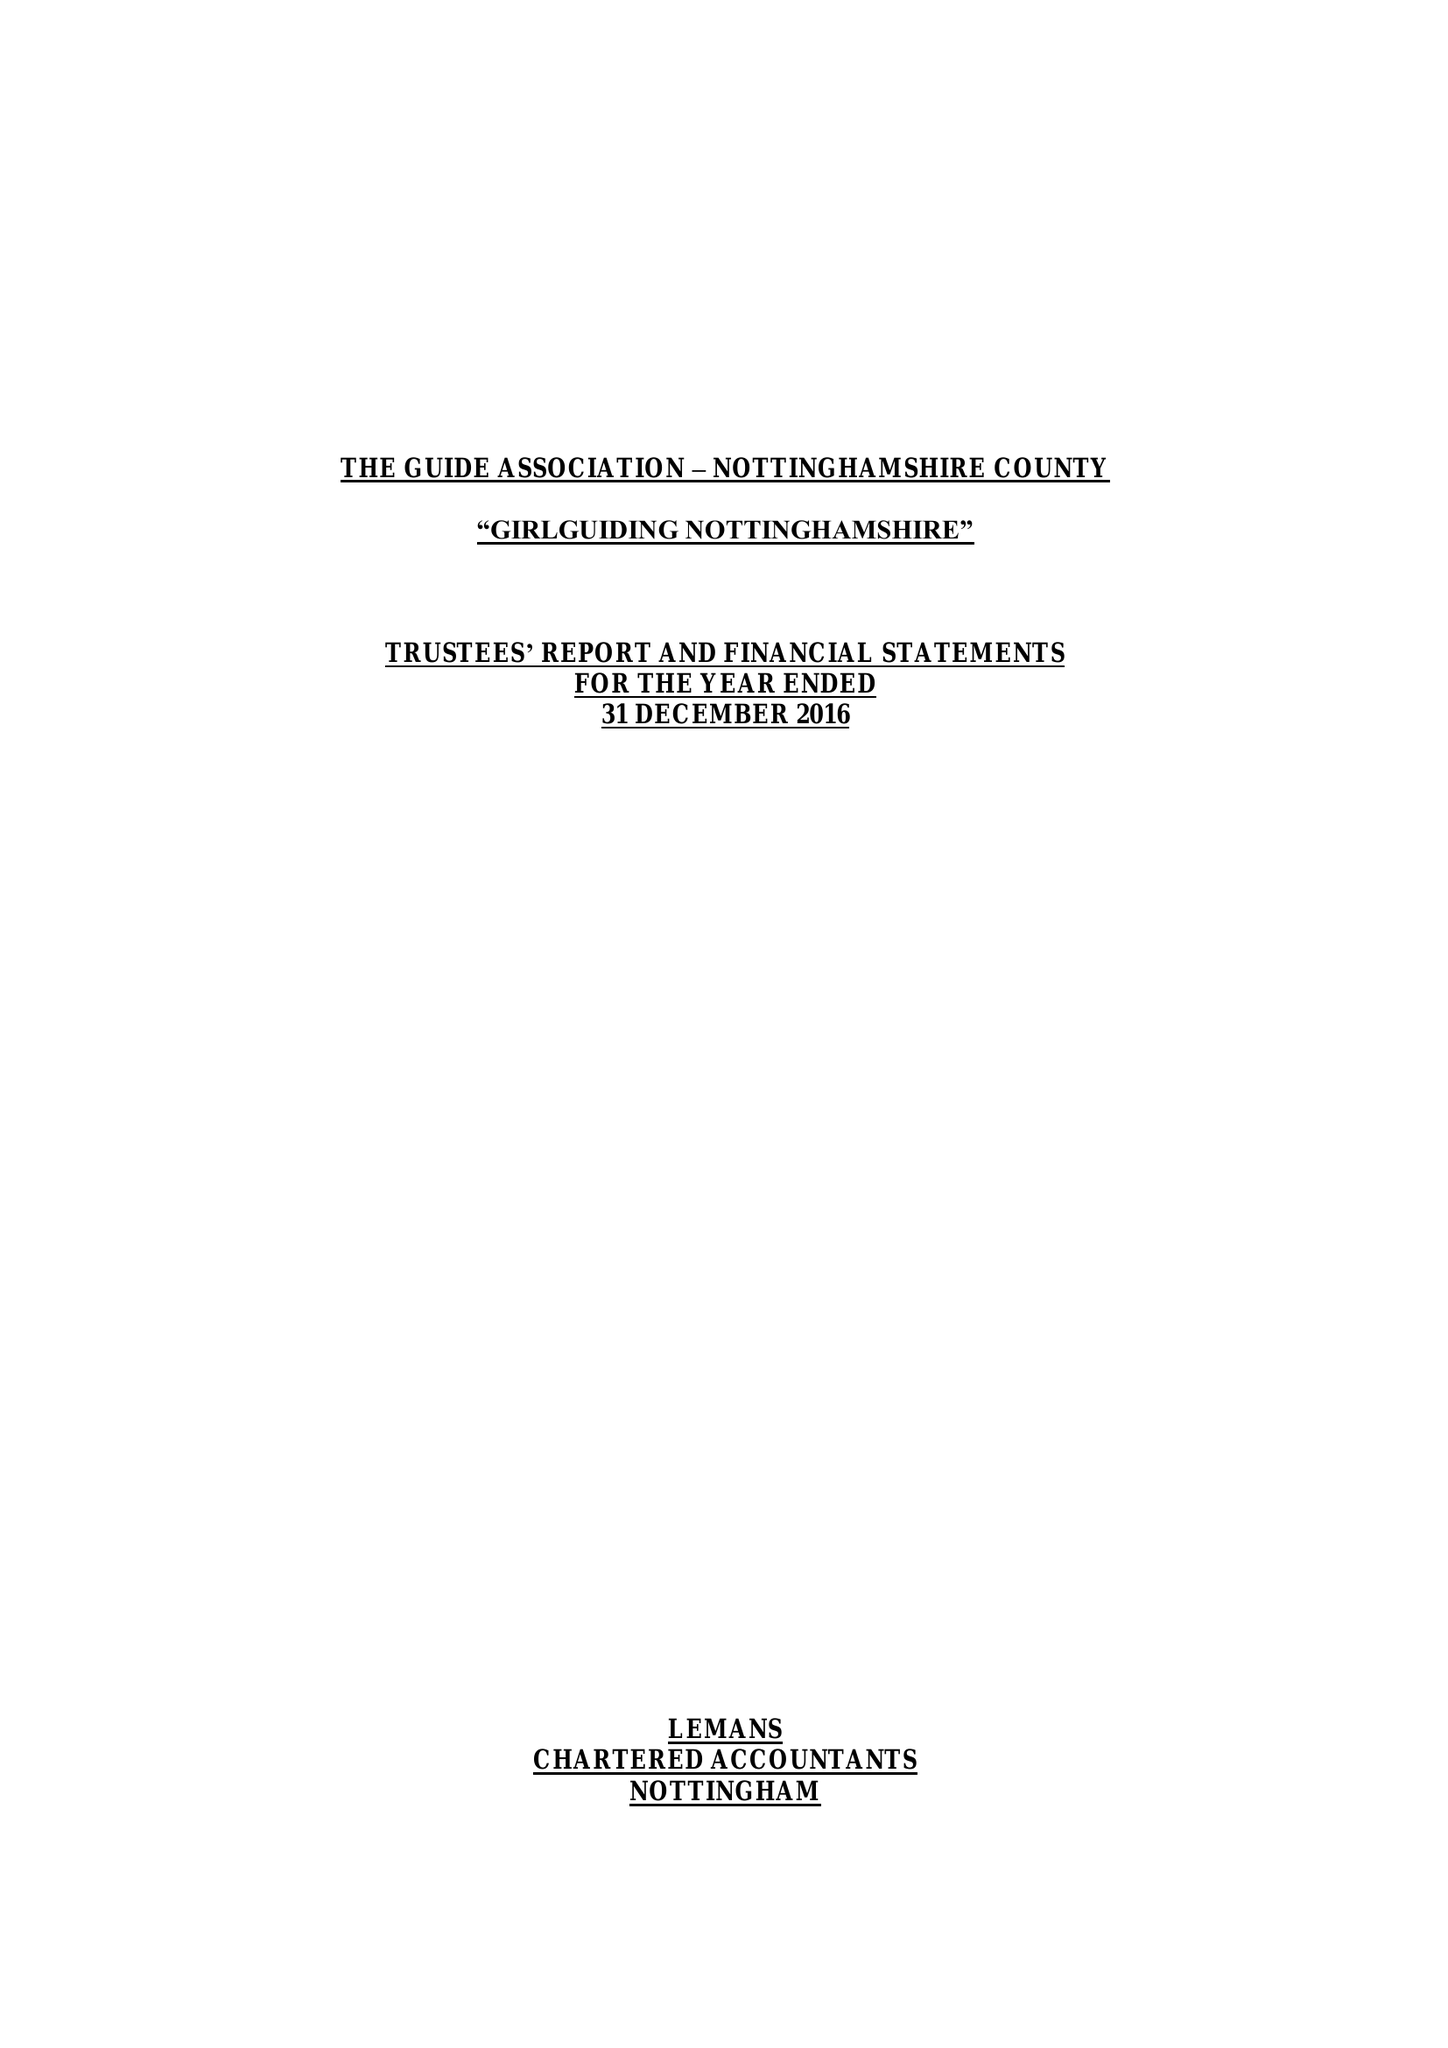What is the value for the income_annually_in_british_pounds?
Answer the question using a single word or phrase. 245876.00 